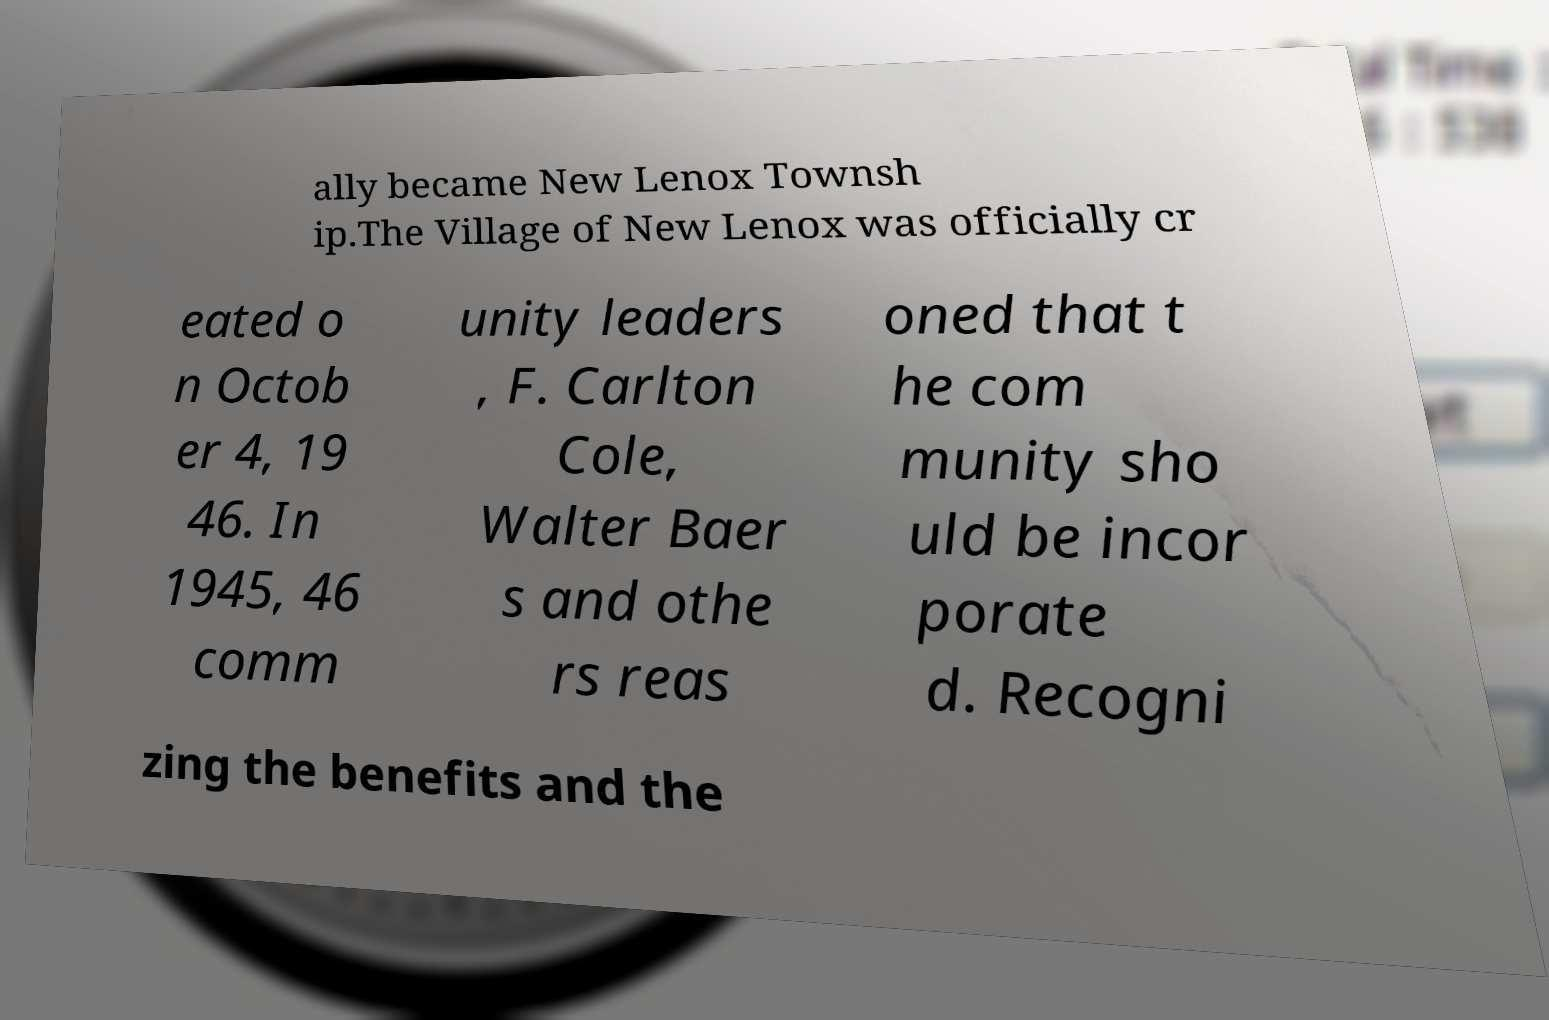Can you accurately transcribe the text from the provided image for me? ally became New Lenox Townsh ip.The Village of New Lenox was officially cr eated o n Octob er 4, 19 46. In 1945, 46 comm unity leaders , F. Carlton Cole, Walter Baer s and othe rs reas oned that t he com munity sho uld be incor porate d. Recogni zing the benefits and the 